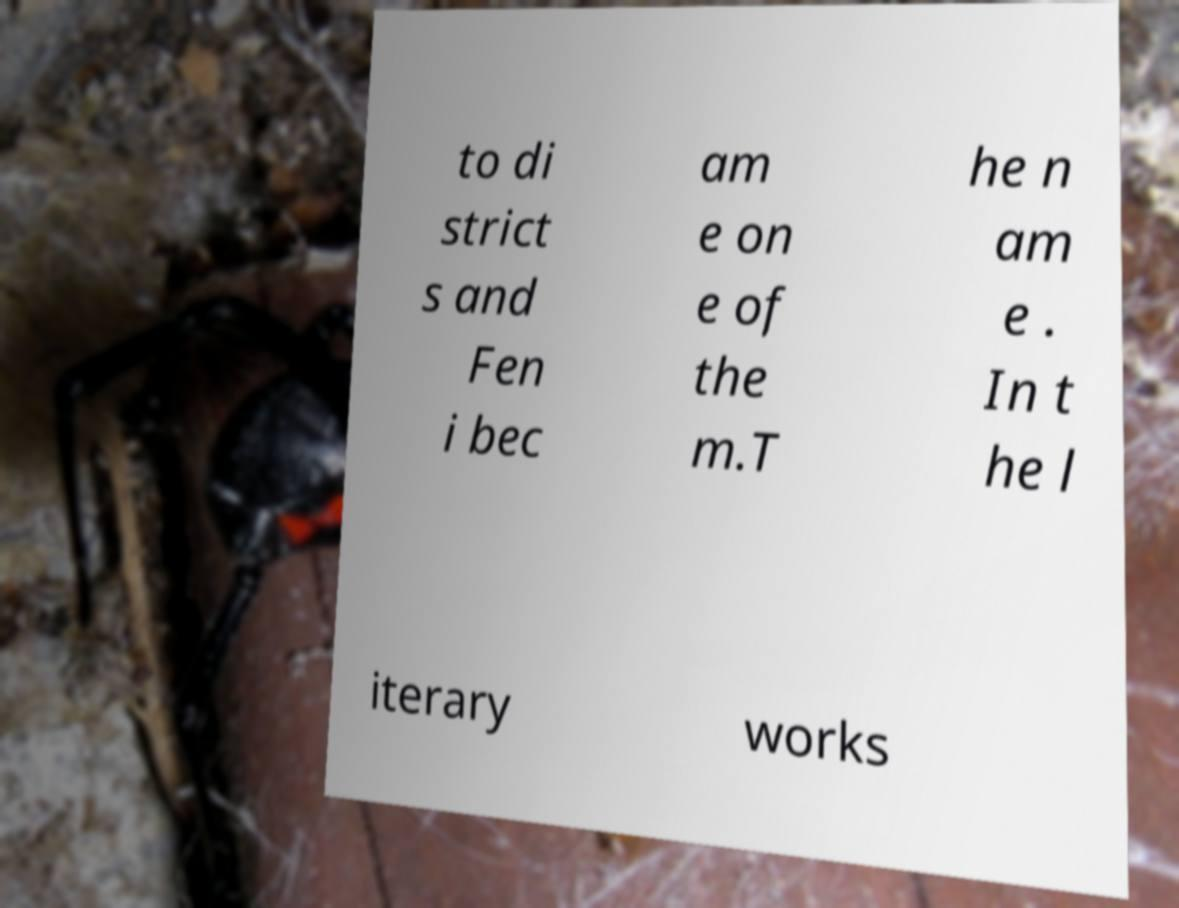Please identify and transcribe the text found in this image. to di strict s and Fen i bec am e on e of the m.T he n am e . In t he l iterary works 